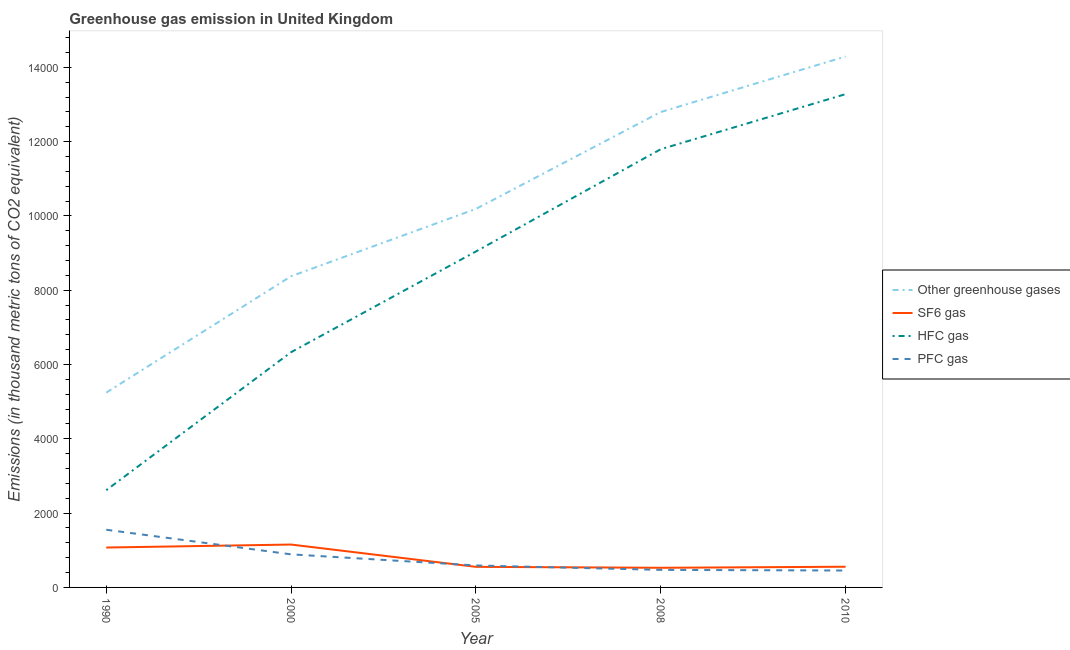What is the emission of hfc gas in 1990?
Provide a short and direct response. 2617.8. Across all years, what is the maximum emission of sf6 gas?
Provide a short and direct response. 1154.1. Across all years, what is the minimum emission of pfc gas?
Provide a short and direct response. 455. In which year was the emission of sf6 gas maximum?
Make the answer very short. 2000. What is the total emission of hfc gas in the graph?
Your response must be concise. 4.31e+04. What is the difference between the emission of pfc gas in 1990 and that in 2000?
Provide a succinct answer. 662.4. What is the difference between the emission of pfc gas in 2005 and the emission of sf6 gas in 2010?
Keep it short and to the point. 34.4. What is the average emission of pfc gas per year?
Your response must be concise. 792.28. In the year 2005, what is the difference between the emission of greenhouse gases and emission of hfc gas?
Give a very brief answer. 1145.6. What is the ratio of the emission of greenhouse gases in 2005 to that in 2008?
Your answer should be very brief. 0.8. What is the difference between the highest and the second highest emission of pfc gas?
Give a very brief answer. 662.4. What is the difference between the highest and the lowest emission of hfc gas?
Offer a very short reply. 1.07e+04. Is the sum of the emission of sf6 gas in 1990 and 2005 greater than the maximum emission of hfc gas across all years?
Offer a terse response. No. Is it the case that in every year, the sum of the emission of greenhouse gases and emission of sf6 gas is greater than the emission of hfc gas?
Your answer should be compact. Yes. Is the emission of greenhouse gases strictly less than the emission of sf6 gas over the years?
Keep it short and to the point. No. How many lines are there?
Provide a short and direct response. 4. How many years are there in the graph?
Provide a succinct answer. 5. Does the graph contain any zero values?
Provide a succinct answer. No. Does the graph contain grids?
Your answer should be very brief. No. Where does the legend appear in the graph?
Provide a succinct answer. Center right. How many legend labels are there?
Offer a very short reply. 4. How are the legend labels stacked?
Ensure brevity in your answer.  Vertical. What is the title of the graph?
Provide a succinct answer. Greenhouse gas emission in United Kingdom. What is the label or title of the X-axis?
Provide a succinct answer. Year. What is the label or title of the Y-axis?
Provide a short and direct response. Emissions (in thousand metric tons of CO2 equivalent). What is the Emissions (in thousand metric tons of CO2 equivalent) of Other greenhouse gases in 1990?
Your response must be concise. 5244.2. What is the Emissions (in thousand metric tons of CO2 equivalent) of SF6 gas in 1990?
Ensure brevity in your answer.  1073.9. What is the Emissions (in thousand metric tons of CO2 equivalent) of HFC gas in 1990?
Offer a terse response. 2617.8. What is the Emissions (in thousand metric tons of CO2 equivalent) in PFC gas in 1990?
Offer a very short reply. 1552.5. What is the Emissions (in thousand metric tons of CO2 equivalent) in Other greenhouse gases in 2000?
Keep it short and to the point. 8376.7. What is the Emissions (in thousand metric tons of CO2 equivalent) in SF6 gas in 2000?
Provide a short and direct response. 1154.1. What is the Emissions (in thousand metric tons of CO2 equivalent) in HFC gas in 2000?
Your answer should be very brief. 6332.5. What is the Emissions (in thousand metric tons of CO2 equivalent) in PFC gas in 2000?
Ensure brevity in your answer.  890.1. What is the Emissions (in thousand metric tons of CO2 equivalent) of Other greenhouse gases in 2005?
Provide a short and direct response. 1.02e+04. What is the Emissions (in thousand metric tons of CO2 equivalent) of SF6 gas in 2005?
Make the answer very short. 554.2. What is the Emissions (in thousand metric tons of CO2 equivalent) of HFC gas in 2005?
Ensure brevity in your answer.  9043.4. What is the Emissions (in thousand metric tons of CO2 equivalent) in PFC gas in 2005?
Ensure brevity in your answer.  591.4. What is the Emissions (in thousand metric tons of CO2 equivalent) in Other greenhouse gases in 2008?
Make the answer very short. 1.28e+04. What is the Emissions (in thousand metric tons of CO2 equivalent) in SF6 gas in 2008?
Offer a terse response. 528.9. What is the Emissions (in thousand metric tons of CO2 equivalent) in HFC gas in 2008?
Your answer should be very brief. 1.18e+04. What is the Emissions (in thousand metric tons of CO2 equivalent) in PFC gas in 2008?
Your answer should be compact. 472.4. What is the Emissions (in thousand metric tons of CO2 equivalent) of Other greenhouse gases in 2010?
Provide a succinct answer. 1.43e+04. What is the Emissions (in thousand metric tons of CO2 equivalent) of SF6 gas in 2010?
Your answer should be compact. 557. What is the Emissions (in thousand metric tons of CO2 equivalent) in HFC gas in 2010?
Give a very brief answer. 1.33e+04. What is the Emissions (in thousand metric tons of CO2 equivalent) in PFC gas in 2010?
Ensure brevity in your answer.  455. Across all years, what is the maximum Emissions (in thousand metric tons of CO2 equivalent) of Other greenhouse gases?
Ensure brevity in your answer.  1.43e+04. Across all years, what is the maximum Emissions (in thousand metric tons of CO2 equivalent) in SF6 gas?
Your response must be concise. 1154.1. Across all years, what is the maximum Emissions (in thousand metric tons of CO2 equivalent) in HFC gas?
Ensure brevity in your answer.  1.33e+04. Across all years, what is the maximum Emissions (in thousand metric tons of CO2 equivalent) of PFC gas?
Make the answer very short. 1552.5. Across all years, what is the minimum Emissions (in thousand metric tons of CO2 equivalent) of Other greenhouse gases?
Offer a terse response. 5244.2. Across all years, what is the minimum Emissions (in thousand metric tons of CO2 equivalent) of SF6 gas?
Offer a very short reply. 528.9. Across all years, what is the minimum Emissions (in thousand metric tons of CO2 equivalent) of HFC gas?
Provide a succinct answer. 2617.8. Across all years, what is the minimum Emissions (in thousand metric tons of CO2 equivalent) of PFC gas?
Your answer should be compact. 455. What is the total Emissions (in thousand metric tons of CO2 equivalent) in Other greenhouse gases in the graph?
Ensure brevity in your answer.  5.09e+04. What is the total Emissions (in thousand metric tons of CO2 equivalent) of SF6 gas in the graph?
Make the answer very short. 3868.1. What is the total Emissions (in thousand metric tons of CO2 equivalent) of HFC gas in the graph?
Make the answer very short. 4.31e+04. What is the total Emissions (in thousand metric tons of CO2 equivalent) of PFC gas in the graph?
Ensure brevity in your answer.  3961.4. What is the difference between the Emissions (in thousand metric tons of CO2 equivalent) in Other greenhouse gases in 1990 and that in 2000?
Keep it short and to the point. -3132.5. What is the difference between the Emissions (in thousand metric tons of CO2 equivalent) in SF6 gas in 1990 and that in 2000?
Your response must be concise. -80.2. What is the difference between the Emissions (in thousand metric tons of CO2 equivalent) in HFC gas in 1990 and that in 2000?
Ensure brevity in your answer.  -3714.7. What is the difference between the Emissions (in thousand metric tons of CO2 equivalent) of PFC gas in 1990 and that in 2000?
Your answer should be very brief. 662.4. What is the difference between the Emissions (in thousand metric tons of CO2 equivalent) of Other greenhouse gases in 1990 and that in 2005?
Ensure brevity in your answer.  -4944.8. What is the difference between the Emissions (in thousand metric tons of CO2 equivalent) in SF6 gas in 1990 and that in 2005?
Your answer should be compact. 519.7. What is the difference between the Emissions (in thousand metric tons of CO2 equivalent) in HFC gas in 1990 and that in 2005?
Offer a terse response. -6425.6. What is the difference between the Emissions (in thousand metric tons of CO2 equivalent) in PFC gas in 1990 and that in 2005?
Offer a terse response. 961.1. What is the difference between the Emissions (in thousand metric tons of CO2 equivalent) in Other greenhouse gases in 1990 and that in 2008?
Make the answer very short. -7553.1. What is the difference between the Emissions (in thousand metric tons of CO2 equivalent) in SF6 gas in 1990 and that in 2008?
Keep it short and to the point. 545. What is the difference between the Emissions (in thousand metric tons of CO2 equivalent) in HFC gas in 1990 and that in 2008?
Keep it short and to the point. -9178.2. What is the difference between the Emissions (in thousand metric tons of CO2 equivalent) in PFC gas in 1990 and that in 2008?
Ensure brevity in your answer.  1080.1. What is the difference between the Emissions (in thousand metric tons of CO2 equivalent) of Other greenhouse gases in 1990 and that in 2010?
Offer a terse response. -9046.8. What is the difference between the Emissions (in thousand metric tons of CO2 equivalent) of SF6 gas in 1990 and that in 2010?
Make the answer very short. 516.9. What is the difference between the Emissions (in thousand metric tons of CO2 equivalent) in HFC gas in 1990 and that in 2010?
Your response must be concise. -1.07e+04. What is the difference between the Emissions (in thousand metric tons of CO2 equivalent) of PFC gas in 1990 and that in 2010?
Provide a succinct answer. 1097.5. What is the difference between the Emissions (in thousand metric tons of CO2 equivalent) of Other greenhouse gases in 2000 and that in 2005?
Offer a terse response. -1812.3. What is the difference between the Emissions (in thousand metric tons of CO2 equivalent) of SF6 gas in 2000 and that in 2005?
Ensure brevity in your answer.  599.9. What is the difference between the Emissions (in thousand metric tons of CO2 equivalent) of HFC gas in 2000 and that in 2005?
Ensure brevity in your answer.  -2710.9. What is the difference between the Emissions (in thousand metric tons of CO2 equivalent) in PFC gas in 2000 and that in 2005?
Provide a succinct answer. 298.7. What is the difference between the Emissions (in thousand metric tons of CO2 equivalent) of Other greenhouse gases in 2000 and that in 2008?
Offer a terse response. -4420.6. What is the difference between the Emissions (in thousand metric tons of CO2 equivalent) in SF6 gas in 2000 and that in 2008?
Ensure brevity in your answer.  625.2. What is the difference between the Emissions (in thousand metric tons of CO2 equivalent) of HFC gas in 2000 and that in 2008?
Provide a short and direct response. -5463.5. What is the difference between the Emissions (in thousand metric tons of CO2 equivalent) of PFC gas in 2000 and that in 2008?
Offer a very short reply. 417.7. What is the difference between the Emissions (in thousand metric tons of CO2 equivalent) in Other greenhouse gases in 2000 and that in 2010?
Your answer should be compact. -5914.3. What is the difference between the Emissions (in thousand metric tons of CO2 equivalent) in SF6 gas in 2000 and that in 2010?
Offer a terse response. 597.1. What is the difference between the Emissions (in thousand metric tons of CO2 equivalent) in HFC gas in 2000 and that in 2010?
Provide a succinct answer. -6946.5. What is the difference between the Emissions (in thousand metric tons of CO2 equivalent) in PFC gas in 2000 and that in 2010?
Offer a terse response. 435.1. What is the difference between the Emissions (in thousand metric tons of CO2 equivalent) in Other greenhouse gases in 2005 and that in 2008?
Offer a terse response. -2608.3. What is the difference between the Emissions (in thousand metric tons of CO2 equivalent) in SF6 gas in 2005 and that in 2008?
Keep it short and to the point. 25.3. What is the difference between the Emissions (in thousand metric tons of CO2 equivalent) of HFC gas in 2005 and that in 2008?
Keep it short and to the point. -2752.6. What is the difference between the Emissions (in thousand metric tons of CO2 equivalent) in PFC gas in 2005 and that in 2008?
Your answer should be compact. 119. What is the difference between the Emissions (in thousand metric tons of CO2 equivalent) of Other greenhouse gases in 2005 and that in 2010?
Provide a succinct answer. -4102. What is the difference between the Emissions (in thousand metric tons of CO2 equivalent) in SF6 gas in 2005 and that in 2010?
Provide a short and direct response. -2.8. What is the difference between the Emissions (in thousand metric tons of CO2 equivalent) in HFC gas in 2005 and that in 2010?
Keep it short and to the point. -4235.6. What is the difference between the Emissions (in thousand metric tons of CO2 equivalent) of PFC gas in 2005 and that in 2010?
Offer a very short reply. 136.4. What is the difference between the Emissions (in thousand metric tons of CO2 equivalent) in Other greenhouse gases in 2008 and that in 2010?
Offer a terse response. -1493.7. What is the difference between the Emissions (in thousand metric tons of CO2 equivalent) in SF6 gas in 2008 and that in 2010?
Your answer should be compact. -28.1. What is the difference between the Emissions (in thousand metric tons of CO2 equivalent) in HFC gas in 2008 and that in 2010?
Provide a short and direct response. -1483. What is the difference between the Emissions (in thousand metric tons of CO2 equivalent) of PFC gas in 2008 and that in 2010?
Provide a short and direct response. 17.4. What is the difference between the Emissions (in thousand metric tons of CO2 equivalent) in Other greenhouse gases in 1990 and the Emissions (in thousand metric tons of CO2 equivalent) in SF6 gas in 2000?
Provide a succinct answer. 4090.1. What is the difference between the Emissions (in thousand metric tons of CO2 equivalent) in Other greenhouse gases in 1990 and the Emissions (in thousand metric tons of CO2 equivalent) in HFC gas in 2000?
Offer a terse response. -1088.3. What is the difference between the Emissions (in thousand metric tons of CO2 equivalent) of Other greenhouse gases in 1990 and the Emissions (in thousand metric tons of CO2 equivalent) of PFC gas in 2000?
Your response must be concise. 4354.1. What is the difference between the Emissions (in thousand metric tons of CO2 equivalent) in SF6 gas in 1990 and the Emissions (in thousand metric tons of CO2 equivalent) in HFC gas in 2000?
Offer a terse response. -5258.6. What is the difference between the Emissions (in thousand metric tons of CO2 equivalent) of SF6 gas in 1990 and the Emissions (in thousand metric tons of CO2 equivalent) of PFC gas in 2000?
Your response must be concise. 183.8. What is the difference between the Emissions (in thousand metric tons of CO2 equivalent) in HFC gas in 1990 and the Emissions (in thousand metric tons of CO2 equivalent) in PFC gas in 2000?
Your answer should be compact. 1727.7. What is the difference between the Emissions (in thousand metric tons of CO2 equivalent) of Other greenhouse gases in 1990 and the Emissions (in thousand metric tons of CO2 equivalent) of SF6 gas in 2005?
Your response must be concise. 4690. What is the difference between the Emissions (in thousand metric tons of CO2 equivalent) of Other greenhouse gases in 1990 and the Emissions (in thousand metric tons of CO2 equivalent) of HFC gas in 2005?
Provide a succinct answer. -3799.2. What is the difference between the Emissions (in thousand metric tons of CO2 equivalent) of Other greenhouse gases in 1990 and the Emissions (in thousand metric tons of CO2 equivalent) of PFC gas in 2005?
Offer a very short reply. 4652.8. What is the difference between the Emissions (in thousand metric tons of CO2 equivalent) in SF6 gas in 1990 and the Emissions (in thousand metric tons of CO2 equivalent) in HFC gas in 2005?
Provide a succinct answer. -7969.5. What is the difference between the Emissions (in thousand metric tons of CO2 equivalent) of SF6 gas in 1990 and the Emissions (in thousand metric tons of CO2 equivalent) of PFC gas in 2005?
Make the answer very short. 482.5. What is the difference between the Emissions (in thousand metric tons of CO2 equivalent) of HFC gas in 1990 and the Emissions (in thousand metric tons of CO2 equivalent) of PFC gas in 2005?
Provide a short and direct response. 2026.4. What is the difference between the Emissions (in thousand metric tons of CO2 equivalent) of Other greenhouse gases in 1990 and the Emissions (in thousand metric tons of CO2 equivalent) of SF6 gas in 2008?
Provide a short and direct response. 4715.3. What is the difference between the Emissions (in thousand metric tons of CO2 equivalent) in Other greenhouse gases in 1990 and the Emissions (in thousand metric tons of CO2 equivalent) in HFC gas in 2008?
Your answer should be compact. -6551.8. What is the difference between the Emissions (in thousand metric tons of CO2 equivalent) in Other greenhouse gases in 1990 and the Emissions (in thousand metric tons of CO2 equivalent) in PFC gas in 2008?
Offer a very short reply. 4771.8. What is the difference between the Emissions (in thousand metric tons of CO2 equivalent) of SF6 gas in 1990 and the Emissions (in thousand metric tons of CO2 equivalent) of HFC gas in 2008?
Keep it short and to the point. -1.07e+04. What is the difference between the Emissions (in thousand metric tons of CO2 equivalent) in SF6 gas in 1990 and the Emissions (in thousand metric tons of CO2 equivalent) in PFC gas in 2008?
Your response must be concise. 601.5. What is the difference between the Emissions (in thousand metric tons of CO2 equivalent) in HFC gas in 1990 and the Emissions (in thousand metric tons of CO2 equivalent) in PFC gas in 2008?
Offer a terse response. 2145.4. What is the difference between the Emissions (in thousand metric tons of CO2 equivalent) in Other greenhouse gases in 1990 and the Emissions (in thousand metric tons of CO2 equivalent) in SF6 gas in 2010?
Your answer should be very brief. 4687.2. What is the difference between the Emissions (in thousand metric tons of CO2 equivalent) in Other greenhouse gases in 1990 and the Emissions (in thousand metric tons of CO2 equivalent) in HFC gas in 2010?
Offer a terse response. -8034.8. What is the difference between the Emissions (in thousand metric tons of CO2 equivalent) of Other greenhouse gases in 1990 and the Emissions (in thousand metric tons of CO2 equivalent) of PFC gas in 2010?
Keep it short and to the point. 4789.2. What is the difference between the Emissions (in thousand metric tons of CO2 equivalent) of SF6 gas in 1990 and the Emissions (in thousand metric tons of CO2 equivalent) of HFC gas in 2010?
Ensure brevity in your answer.  -1.22e+04. What is the difference between the Emissions (in thousand metric tons of CO2 equivalent) of SF6 gas in 1990 and the Emissions (in thousand metric tons of CO2 equivalent) of PFC gas in 2010?
Provide a succinct answer. 618.9. What is the difference between the Emissions (in thousand metric tons of CO2 equivalent) of HFC gas in 1990 and the Emissions (in thousand metric tons of CO2 equivalent) of PFC gas in 2010?
Give a very brief answer. 2162.8. What is the difference between the Emissions (in thousand metric tons of CO2 equivalent) of Other greenhouse gases in 2000 and the Emissions (in thousand metric tons of CO2 equivalent) of SF6 gas in 2005?
Make the answer very short. 7822.5. What is the difference between the Emissions (in thousand metric tons of CO2 equivalent) of Other greenhouse gases in 2000 and the Emissions (in thousand metric tons of CO2 equivalent) of HFC gas in 2005?
Your response must be concise. -666.7. What is the difference between the Emissions (in thousand metric tons of CO2 equivalent) in Other greenhouse gases in 2000 and the Emissions (in thousand metric tons of CO2 equivalent) in PFC gas in 2005?
Ensure brevity in your answer.  7785.3. What is the difference between the Emissions (in thousand metric tons of CO2 equivalent) in SF6 gas in 2000 and the Emissions (in thousand metric tons of CO2 equivalent) in HFC gas in 2005?
Provide a succinct answer. -7889.3. What is the difference between the Emissions (in thousand metric tons of CO2 equivalent) of SF6 gas in 2000 and the Emissions (in thousand metric tons of CO2 equivalent) of PFC gas in 2005?
Offer a very short reply. 562.7. What is the difference between the Emissions (in thousand metric tons of CO2 equivalent) of HFC gas in 2000 and the Emissions (in thousand metric tons of CO2 equivalent) of PFC gas in 2005?
Provide a succinct answer. 5741.1. What is the difference between the Emissions (in thousand metric tons of CO2 equivalent) in Other greenhouse gases in 2000 and the Emissions (in thousand metric tons of CO2 equivalent) in SF6 gas in 2008?
Offer a very short reply. 7847.8. What is the difference between the Emissions (in thousand metric tons of CO2 equivalent) of Other greenhouse gases in 2000 and the Emissions (in thousand metric tons of CO2 equivalent) of HFC gas in 2008?
Provide a short and direct response. -3419.3. What is the difference between the Emissions (in thousand metric tons of CO2 equivalent) in Other greenhouse gases in 2000 and the Emissions (in thousand metric tons of CO2 equivalent) in PFC gas in 2008?
Ensure brevity in your answer.  7904.3. What is the difference between the Emissions (in thousand metric tons of CO2 equivalent) in SF6 gas in 2000 and the Emissions (in thousand metric tons of CO2 equivalent) in HFC gas in 2008?
Keep it short and to the point. -1.06e+04. What is the difference between the Emissions (in thousand metric tons of CO2 equivalent) in SF6 gas in 2000 and the Emissions (in thousand metric tons of CO2 equivalent) in PFC gas in 2008?
Provide a short and direct response. 681.7. What is the difference between the Emissions (in thousand metric tons of CO2 equivalent) in HFC gas in 2000 and the Emissions (in thousand metric tons of CO2 equivalent) in PFC gas in 2008?
Provide a succinct answer. 5860.1. What is the difference between the Emissions (in thousand metric tons of CO2 equivalent) in Other greenhouse gases in 2000 and the Emissions (in thousand metric tons of CO2 equivalent) in SF6 gas in 2010?
Ensure brevity in your answer.  7819.7. What is the difference between the Emissions (in thousand metric tons of CO2 equivalent) in Other greenhouse gases in 2000 and the Emissions (in thousand metric tons of CO2 equivalent) in HFC gas in 2010?
Make the answer very short. -4902.3. What is the difference between the Emissions (in thousand metric tons of CO2 equivalent) of Other greenhouse gases in 2000 and the Emissions (in thousand metric tons of CO2 equivalent) of PFC gas in 2010?
Make the answer very short. 7921.7. What is the difference between the Emissions (in thousand metric tons of CO2 equivalent) of SF6 gas in 2000 and the Emissions (in thousand metric tons of CO2 equivalent) of HFC gas in 2010?
Ensure brevity in your answer.  -1.21e+04. What is the difference between the Emissions (in thousand metric tons of CO2 equivalent) in SF6 gas in 2000 and the Emissions (in thousand metric tons of CO2 equivalent) in PFC gas in 2010?
Offer a terse response. 699.1. What is the difference between the Emissions (in thousand metric tons of CO2 equivalent) of HFC gas in 2000 and the Emissions (in thousand metric tons of CO2 equivalent) of PFC gas in 2010?
Offer a very short reply. 5877.5. What is the difference between the Emissions (in thousand metric tons of CO2 equivalent) of Other greenhouse gases in 2005 and the Emissions (in thousand metric tons of CO2 equivalent) of SF6 gas in 2008?
Provide a short and direct response. 9660.1. What is the difference between the Emissions (in thousand metric tons of CO2 equivalent) of Other greenhouse gases in 2005 and the Emissions (in thousand metric tons of CO2 equivalent) of HFC gas in 2008?
Your response must be concise. -1607. What is the difference between the Emissions (in thousand metric tons of CO2 equivalent) of Other greenhouse gases in 2005 and the Emissions (in thousand metric tons of CO2 equivalent) of PFC gas in 2008?
Make the answer very short. 9716.6. What is the difference between the Emissions (in thousand metric tons of CO2 equivalent) in SF6 gas in 2005 and the Emissions (in thousand metric tons of CO2 equivalent) in HFC gas in 2008?
Offer a very short reply. -1.12e+04. What is the difference between the Emissions (in thousand metric tons of CO2 equivalent) in SF6 gas in 2005 and the Emissions (in thousand metric tons of CO2 equivalent) in PFC gas in 2008?
Give a very brief answer. 81.8. What is the difference between the Emissions (in thousand metric tons of CO2 equivalent) of HFC gas in 2005 and the Emissions (in thousand metric tons of CO2 equivalent) of PFC gas in 2008?
Offer a very short reply. 8571. What is the difference between the Emissions (in thousand metric tons of CO2 equivalent) in Other greenhouse gases in 2005 and the Emissions (in thousand metric tons of CO2 equivalent) in SF6 gas in 2010?
Offer a terse response. 9632. What is the difference between the Emissions (in thousand metric tons of CO2 equivalent) of Other greenhouse gases in 2005 and the Emissions (in thousand metric tons of CO2 equivalent) of HFC gas in 2010?
Your response must be concise. -3090. What is the difference between the Emissions (in thousand metric tons of CO2 equivalent) of Other greenhouse gases in 2005 and the Emissions (in thousand metric tons of CO2 equivalent) of PFC gas in 2010?
Give a very brief answer. 9734. What is the difference between the Emissions (in thousand metric tons of CO2 equivalent) of SF6 gas in 2005 and the Emissions (in thousand metric tons of CO2 equivalent) of HFC gas in 2010?
Your response must be concise. -1.27e+04. What is the difference between the Emissions (in thousand metric tons of CO2 equivalent) in SF6 gas in 2005 and the Emissions (in thousand metric tons of CO2 equivalent) in PFC gas in 2010?
Provide a short and direct response. 99.2. What is the difference between the Emissions (in thousand metric tons of CO2 equivalent) in HFC gas in 2005 and the Emissions (in thousand metric tons of CO2 equivalent) in PFC gas in 2010?
Keep it short and to the point. 8588.4. What is the difference between the Emissions (in thousand metric tons of CO2 equivalent) of Other greenhouse gases in 2008 and the Emissions (in thousand metric tons of CO2 equivalent) of SF6 gas in 2010?
Provide a short and direct response. 1.22e+04. What is the difference between the Emissions (in thousand metric tons of CO2 equivalent) in Other greenhouse gases in 2008 and the Emissions (in thousand metric tons of CO2 equivalent) in HFC gas in 2010?
Offer a terse response. -481.7. What is the difference between the Emissions (in thousand metric tons of CO2 equivalent) of Other greenhouse gases in 2008 and the Emissions (in thousand metric tons of CO2 equivalent) of PFC gas in 2010?
Provide a short and direct response. 1.23e+04. What is the difference between the Emissions (in thousand metric tons of CO2 equivalent) of SF6 gas in 2008 and the Emissions (in thousand metric tons of CO2 equivalent) of HFC gas in 2010?
Offer a terse response. -1.28e+04. What is the difference between the Emissions (in thousand metric tons of CO2 equivalent) in SF6 gas in 2008 and the Emissions (in thousand metric tons of CO2 equivalent) in PFC gas in 2010?
Make the answer very short. 73.9. What is the difference between the Emissions (in thousand metric tons of CO2 equivalent) in HFC gas in 2008 and the Emissions (in thousand metric tons of CO2 equivalent) in PFC gas in 2010?
Offer a terse response. 1.13e+04. What is the average Emissions (in thousand metric tons of CO2 equivalent) of Other greenhouse gases per year?
Your answer should be compact. 1.02e+04. What is the average Emissions (in thousand metric tons of CO2 equivalent) in SF6 gas per year?
Offer a very short reply. 773.62. What is the average Emissions (in thousand metric tons of CO2 equivalent) in HFC gas per year?
Provide a short and direct response. 8613.74. What is the average Emissions (in thousand metric tons of CO2 equivalent) of PFC gas per year?
Offer a very short reply. 792.28. In the year 1990, what is the difference between the Emissions (in thousand metric tons of CO2 equivalent) of Other greenhouse gases and Emissions (in thousand metric tons of CO2 equivalent) of SF6 gas?
Ensure brevity in your answer.  4170.3. In the year 1990, what is the difference between the Emissions (in thousand metric tons of CO2 equivalent) in Other greenhouse gases and Emissions (in thousand metric tons of CO2 equivalent) in HFC gas?
Give a very brief answer. 2626.4. In the year 1990, what is the difference between the Emissions (in thousand metric tons of CO2 equivalent) of Other greenhouse gases and Emissions (in thousand metric tons of CO2 equivalent) of PFC gas?
Keep it short and to the point. 3691.7. In the year 1990, what is the difference between the Emissions (in thousand metric tons of CO2 equivalent) in SF6 gas and Emissions (in thousand metric tons of CO2 equivalent) in HFC gas?
Make the answer very short. -1543.9. In the year 1990, what is the difference between the Emissions (in thousand metric tons of CO2 equivalent) of SF6 gas and Emissions (in thousand metric tons of CO2 equivalent) of PFC gas?
Your response must be concise. -478.6. In the year 1990, what is the difference between the Emissions (in thousand metric tons of CO2 equivalent) of HFC gas and Emissions (in thousand metric tons of CO2 equivalent) of PFC gas?
Your response must be concise. 1065.3. In the year 2000, what is the difference between the Emissions (in thousand metric tons of CO2 equivalent) of Other greenhouse gases and Emissions (in thousand metric tons of CO2 equivalent) of SF6 gas?
Provide a succinct answer. 7222.6. In the year 2000, what is the difference between the Emissions (in thousand metric tons of CO2 equivalent) of Other greenhouse gases and Emissions (in thousand metric tons of CO2 equivalent) of HFC gas?
Your answer should be very brief. 2044.2. In the year 2000, what is the difference between the Emissions (in thousand metric tons of CO2 equivalent) of Other greenhouse gases and Emissions (in thousand metric tons of CO2 equivalent) of PFC gas?
Your answer should be very brief. 7486.6. In the year 2000, what is the difference between the Emissions (in thousand metric tons of CO2 equivalent) in SF6 gas and Emissions (in thousand metric tons of CO2 equivalent) in HFC gas?
Keep it short and to the point. -5178.4. In the year 2000, what is the difference between the Emissions (in thousand metric tons of CO2 equivalent) of SF6 gas and Emissions (in thousand metric tons of CO2 equivalent) of PFC gas?
Your response must be concise. 264. In the year 2000, what is the difference between the Emissions (in thousand metric tons of CO2 equivalent) of HFC gas and Emissions (in thousand metric tons of CO2 equivalent) of PFC gas?
Offer a very short reply. 5442.4. In the year 2005, what is the difference between the Emissions (in thousand metric tons of CO2 equivalent) in Other greenhouse gases and Emissions (in thousand metric tons of CO2 equivalent) in SF6 gas?
Provide a short and direct response. 9634.8. In the year 2005, what is the difference between the Emissions (in thousand metric tons of CO2 equivalent) of Other greenhouse gases and Emissions (in thousand metric tons of CO2 equivalent) of HFC gas?
Keep it short and to the point. 1145.6. In the year 2005, what is the difference between the Emissions (in thousand metric tons of CO2 equivalent) of Other greenhouse gases and Emissions (in thousand metric tons of CO2 equivalent) of PFC gas?
Provide a short and direct response. 9597.6. In the year 2005, what is the difference between the Emissions (in thousand metric tons of CO2 equivalent) in SF6 gas and Emissions (in thousand metric tons of CO2 equivalent) in HFC gas?
Give a very brief answer. -8489.2. In the year 2005, what is the difference between the Emissions (in thousand metric tons of CO2 equivalent) in SF6 gas and Emissions (in thousand metric tons of CO2 equivalent) in PFC gas?
Offer a terse response. -37.2. In the year 2005, what is the difference between the Emissions (in thousand metric tons of CO2 equivalent) in HFC gas and Emissions (in thousand metric tons of CO2 equivalent) in PFC gas?
Keep it short and to the point. 8452. In the year 2008, what is the difference between the Emissions (in thousand metric tons of CO2 equivalent) of Other greenhouse gases and Emissions (in thousand metric tons of CO2 equivalent) of SF6 gas?
Ensure brevity in your answer.  1.23e+04. In the year 2008, what is the difference between the Emissions (in thousand metric tons of CO2 equivalent) of Other greenhouse gases and Emissions (in thousand metric tons of CO2 equivalent) of HFC gas?
Offer a terse response. 1001.3. In the year 2008, what is the difference between the Emissions (in thousand metric tons of CO2 equivalent) of Other greenhouse gases and Emissions (in thousand metric tons of CO2 equivalent) of PFC gas?
Keep it short and to the point. 1.23e+04. In the year 2008, what is the difference between the Emissions (in thousand metric tons of CO2 equivalent) in SF6 gas and Emissions (in thousand metric tons of CO2 equivalent) in HFC gas?
Provide a short and direct response. -1.13e+04. In the year 2008, what is the difference between the Emissions (in thousand metric tons of CO2 equivalent) in SF6 gas and Emissions (in thousand metric tons of CO2 equivalent) in PFC gas?
Offer a terse response. 56.5. In the year 2008, what is the difference between the Emissions (in thousand metric tons of CO2 equivalent) of HFC gas and Emissions (in thousand metric tons of CO2 equivalent) of PFC gas?
Your answer should be compact. 1.13e+04. In the year 2010, what is the difference between the Emissions (in thousand metric tons of CO2 equivalent) of Other greenhouse gases and Emissions (in thousand metric tons of CO2 equivalent) of SF6 gas?
Ensure brevity in your answer.  1.37e+04. In the year 2010, what is the difference between the Emissions (in thousand metric tons of CO2 equivalent) in Other greenhouse gases and Emissions (in thousand metric tons of CO2 equivalent) in HFC gas?
Your answer should be very brief. 1012. In the year 2010, what is the difference between the Emissions (in thousand metric tons of CO2 equivalent) in Other greenhouse gases and Emissions (in thousand metric tons of CO2 equivalent) in PFC gas?
Your answer should be compact. 1.38e+04. In the year 2010, what is the difference between the Emissions (in thousand metric tons of CO2 equivalent) in SF6 gas and Emissions (in thousand metric tons of CO2 equivalent) in HFC gas?
Provide a succinct answer. -1.27e+04. In the year 2010, what is the difference between the Emissions (in thousand metric tons of CO2 equivalent) of SF6 gas and Emissions (in thousand metric tons of CO2 equivalent) of PFC gas?
Provide a short and direct response. 102. In the year 2010, what is the difference between the Emissions (in thousand metric tons of CO2 equivalent) of HFC gas and Emissions (in thousand metric tons of CO2 equivalent) of PFC gas?
Your answer should be very brief. 1.28e+04. What is the ratio of the Emissions (in thousand metric tons of CO2 equivalent) of Other greenhouse gases in 1990 to that in 2000?
Offer a terse response. 0.63. What is the ratio of the Emissions (in thousand metric tons of CO2 equivalent) of SF6 gas in 1990 to that in 2000?
Provide a succinct answer. 0.93. What is the ratio of the Emissions (in thousand metric tons of CO2 equivalent) in HFC gas in 1990 to that in 2000?
Ensure brevity in your answer.  0.41. What is the ratio of the Emissions (in thousand metric tons of CO2 equivalent) of PFC gas in 1990 to that in 2000?
Make the answer very short. 1.74. What is the ratio of the Emissions (in thousand metric tons of CO2 equivalent) in Other greenhouse gases in 1990 to that in 2005?
Offer a very short reply. 0.51. What is the ratio of the Emissions (in thousand metric tons of CO2 equivalent) of SF6 gas in 1990 to that in 2005?
Your response must be concise. 1.94. What is the ratio of the Emissions (in thousand metric tons of CO2 equivalent) of HFC gas in 1990 to that in 2005?
Provide a succinct answer. 0.29. What is the ratio of the Emissions (in thousand metric tons of CO2 equivalent) of PFC gas in 1990 to that in 2005?
Offer a very short reply. 2.63. What is the ratio of the Emissions (in thousand metric tons of CO2 equivalent) in Other greenhouse gases in 1990 to that in 2008?
Provide a short and direct response. 0.41. What is the ratio of the Emissions (in thousand metric tons of CO2 equivalent) of SF6 gas in 1990 to that in 2008?
Provide a short and direct response. 2.03. What is the ratio of the Emissions (in thousand metric tons of CO2 equivalent) of HFC gas in 1990 to that in 2008?
Provide a succinct answer. 0.22. What is the ratio of the Emissions (in thousand metric tons of CO2 equivalent) in PFC gas in 1990 to that in 2008?
Provide a succinct answer. 3.29. What is the ratio of the Emissions (in thousand metric tons of CO2 equivalent) of Other greenhouse gases in 1990 to that in 2010?
Your answer should be compact. 0.37. What is the ratio of the Emissions (in thousand metric tons of CO2 equivalent) in SF6 gas in 1990 to that in 2010?
Your response must be concise. 1.93. What is the ratio of the Emissions (in thousand metric tons of CO2 equivalent) in HFC gas in 1990 to that in 2010?
Your answer should be very brief. 0.2. What is the ratio of the Emissions (in thousand metric tons of CO2 equivalent) of PFC gas in 1990 to that in 2010?
Your response must be concise. 3.41. What is the ratio of the Emissions (in thousand metric tons of CO2 equivalent) of Other greenhouse gases in 2000 to that in 2005?
Make the answer very short. 0.82. What is the ratio of the Emissions (in thousand metric tons of CO2 equivalent) of SF6 gas in 2000 to that in 2005?
Keep it short and to the point. 2.08. What is the ratio of the Emissions (in thousand metric tons of CO2 equivalent) in HFC gas in 2000 to that in 2005?
Make the answer very short. 0.7. What is the ratio of the Emissions (in thousand metric tons of CO2 equivalent) in PFC gas in 2000 to that in 2005?
Keep it short and to the point. 1.51. What is the ratio of the Emissions (in thousand metric tons of CO2 equivalent) of Other greenhouse gases in 2000 to that in 2008?
Give a very brief answer. 0.65. What is the ratio of the Emissions (in thousand metric tons of CO2 equivalent) in SF6 gas in 2000 to that in 2008?
Provide a short and direct response. 2.18. What is the ratio of the Emissions (in thousand metric tons of CO2 equivalent) in HFC gas in 2000 to that in 2008?
Provide a succinct answer. 0.54. What is the ratio of the Emissions (in thousand metric tons of CO2 equivalent) in PFC gas in 2000 to that in 2008?
Your answer should be very brief. 1.88. What is the ratio of the Emissions (in thousand metric tons of CO2 equivalent) in Other greenhouse gases in 2000 to that in 2010?
Keep it short and to the point. 0.59. What is the ratio of the Emissions (in thousand metric tons of CO2 equivalent) of SF6 gas in 2000 to that in 2010?
Your answer should be compact. 2.07. What is the ratio of the Emissions (in thousand metric tons of CO2 equivalent) in HFC gas in 2000 to that in 2010?
Give a very brief answer. 0.48. What is the ratio of the Emissions (in thousand metric tons of CO2 equivalent) of PFC gas in 2000 to that in 2010?
Give a very brief answer. 1.96. What is the ratio of the Emissions (in thousand metric tons of CO2 equivalent) in Other greenhouse gases in 2005 to that in 2008?
Give a very brief answer. 0.8. What is the ratio of the Emissions (in thousand metric tons of CO2 equivalent) in SF6 gas in 2005 to that in 2008?
Your response must be concise. 1.05. What is the ratio of the Emissions (in thousand metric tons of CO2 equivalent) of HFC gas in 2005 to that in 2008?
Your answer should be compact. 0.77. What is the ratio of the Emissions (in thousand metric tons of CO2 equivalent) in PFC gas in 2005 to that in 2008?
Provide a short and direct response. 1.25. What is the ratio of the Emissions (in thousand metric tons of CO2 equivalent) in Other greenhouse gases in 2005 to that in 2010?
Offer a terse response. 0.71. What is the ratio of the Emissions (in thousand metric tons of CO2 equivalent) in HFC gas in 2005 to that in 2010?
Offer a terse response. 0.68. What is the ratio of the Emissions (in thousand metric tons of CO2 equivalent) in PFC gas in 2005 to that in 2010?
Provide a short and direct response. 1.3. What is the ratio of the Emissions (in thousand metric tons of CO2 equivalent) in Other greenhouse gases in 2008 to that in 2010?
Ensure brevity in your answer.  0.9. What is the ratio of the Emissions (in thousand metric tons of CO2 equivalent) in SF6 gas in 2008 to that in 2010?
Provide a short and direct response. 0.95. What is the ratio of the Emissions (in thousand metric tons of CO2 equivalent) of HFC gas in 2008 to that in 2010?
Provide a succinct answer. 0.89. What is the ratio of the Emissions (in thousand metric tons of CO2 equivalent) in PFC gas in 2008 to that in 2010?
Make the answer very short. 1.04. What is the difference between the highest and the second highest Emissions (in thousand metric tons of CO2 equivalent) of Other greenhouse gases?
Provide a succinct answer. 1493.7. What is the difference between the highest and the second highest Emissions (in thousand metric tons of CO2 equivalent) of SF6 gas?
Give a very brief answer. 80.2. What is the difference between the highest and the second highest Emissions (in thousand metric tons of CO2 equivalent) of HFC gas?
Your response must be concise. 1483. What is the difference between the highest and the second highest Emissions (in thousand metric tons of CO2 equivalent) in PFC gas?
Offer a very short reply. 662.4. What is the difference between the highest and the lowest Emissions (in thousand metric tons of CO2 equivalent) in Other greenhouse gases?
Give a very brief answer. 9046.8. What is the difference between the highest and the lowest Emissions (in thousand metric tons of CO2 equivalent) in SF6 gas?
Provide a succinct answer. 625.2. What is the difference between the highest and the lowest Emissions (in thousand metric tons of CO2 equivalent) in HFC gas?
Your answer should be compact. 1.07e+04. What is the difference between the highest and the lowest Emissions (in thousand metric tons of CO2 equivalent) of PFC gas?
Keep it short and to the point. 1097.5. 